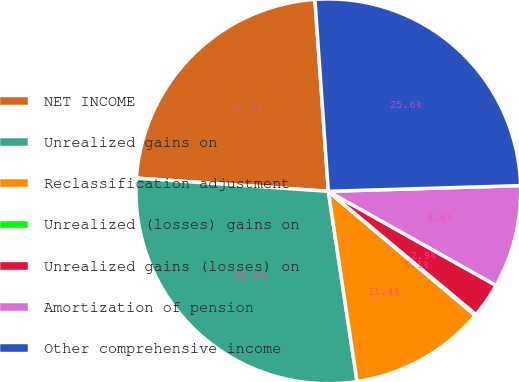<chart> <loc_0><loc_0><loc_500><loc_500><pie_chart><fcel>NET INCOME<fcel>Unrealized gains on<fcel>Reclassification adjustment<fcel>Unrealized (losses) gains on<fcel>Unrealized gains (losses) on<fcel>Amortization of pension<fcel>Other comprehensive income<nl><fcel>22.8%<fcel>28.48%<fcel>11.45%<fcel>0.1%<fcel>2.93%<fcel>8.61%<fcel>25.64%<nl></chart> 